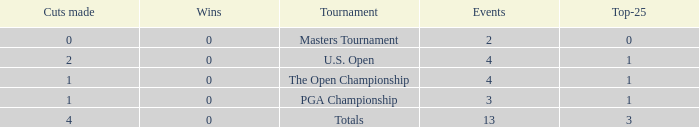How many cuts made in the tournament he played 13 times? None. 